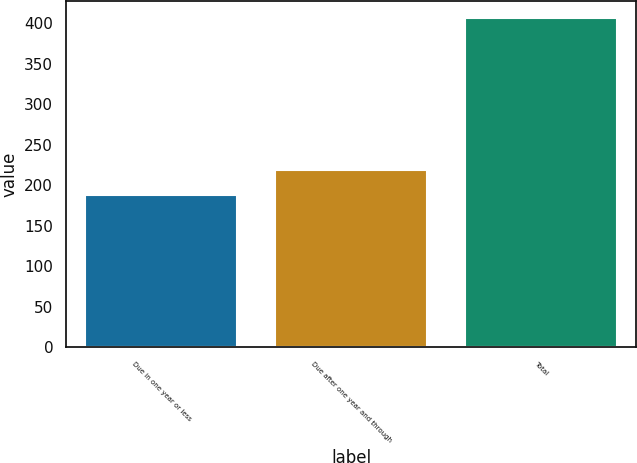Convert chart. <chart><loc_0><loc_0><loc_500><loc_500><bar_chart><fcel>Due in one year or less<fcel>Due after one year and through<fcel>Total<nl><fcel>188<fcel>219<fcel>407<nl></chart> 